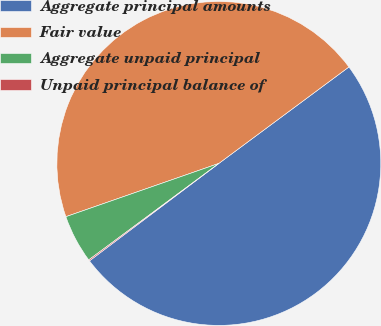Convert chart to OTSL. <chart><loc_0><loc_0><loc_500><loc_500><pie_chart><fcel>Aggregate principal amounts<fcel>Fair value<fcel>Aggregate unpaid principal<fcel>Unpaid principal balance of<nl><fcel>49.88%<fcel>45.18%<fcel>4.82%<fcel>0.12%<nl></chart> 